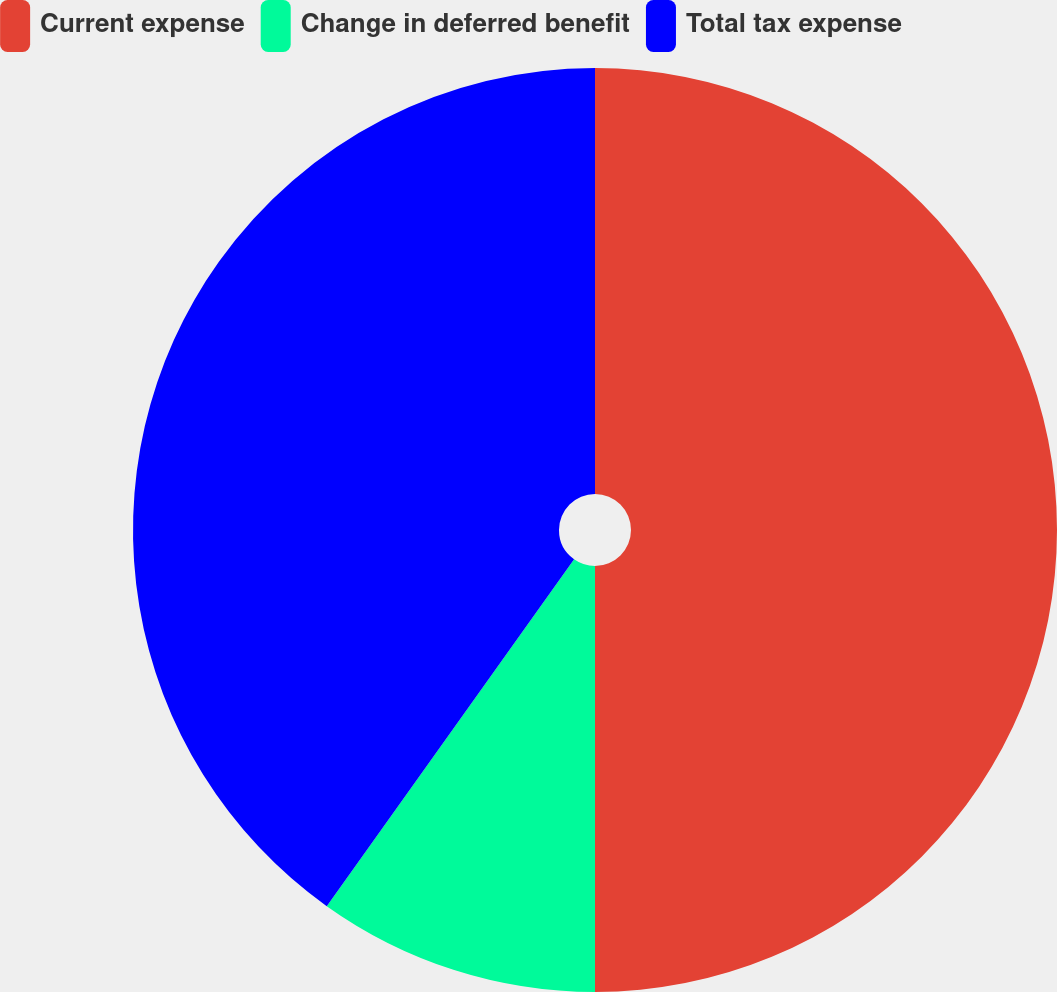<chart> <loc_0><loc_0><loc_500><loc_500><pie_chart><fcel>Current expense<fcel>Change in deferred benefit<fcel>Total tax expense<nl><fcel>50.0%<fcel>9.86%<fcel>40.14%<nl></chart> 